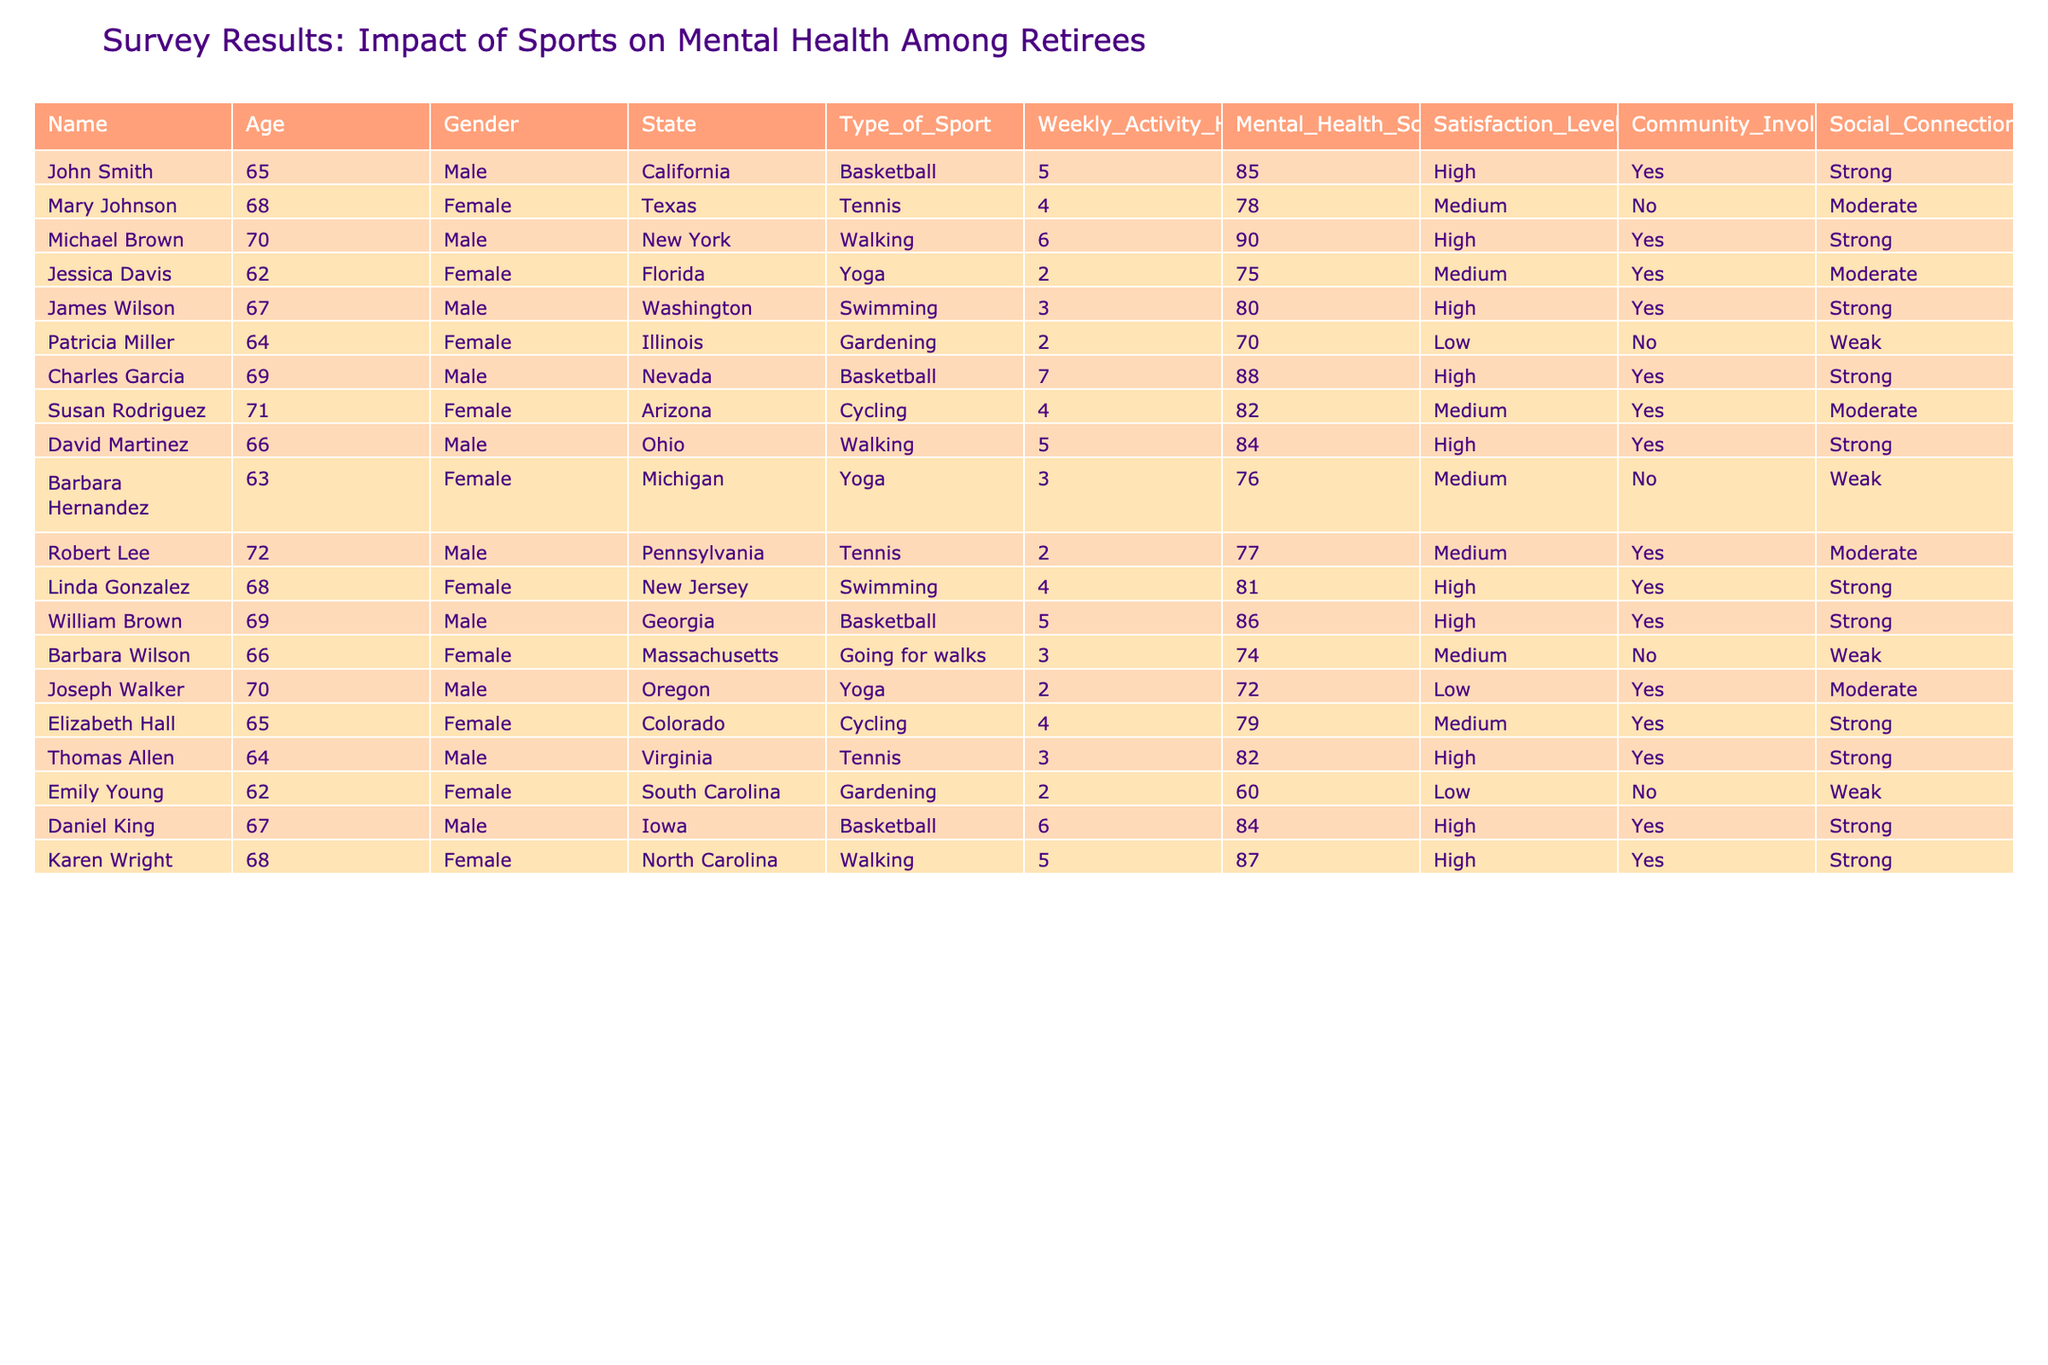What is the mental health score of John Smith? According to the table, John Smith has a mental health score of 85.
Answer: 85 Which retiree has the highest weekly activity hours? By looking at the table, Charles Garcia has the highest weekly activity hours at 7 hours.
Answer: 7 hours How many retirees participate in basketball? The table shows that 4 retirees are involved in basketball: John Smith, Charles Garcia, William Brown, and Daniel King.
Answer: 4 retirees What is the average mental health score of retirees who play yoga? The mental health scores for retirees participating in yoga are 75, 76, and 72. Adding them gives 223, and dividing by the 3 participants gives an average of 74.33.
Answer: 74.33 Is Susan Rodriguez involved in community activities? The table indicates that Susan Rodriguez does engage in community involvement.
Answer: Yes What is the satisfaction level of retirees who engage in swimming? The satisfaction levels for swimming retirees are high (80) and high (81). Average them, which gives 80.5.
Answer: 80.5 Which sport has the highest average mental health score among retirees? To find this, sum the mental health scores for each sport: Basketball (85+88+86+84=343, average 85.75), Tennis (78+77+82=237, average 79), Yoga (75+76+72=223, average 74.33), Walking (90+84+87=261, average 87), Swimming (80+81=161, average 80.5), Cycling (82+79=161, average 80.5), Gardening (70+60=130, average 65). Basketball has the highest average at 85.75.
Answer: Basketball Which gender has a higher proportion of retirees with a high satisfaction level? Looking at the table, 7 males have high satisfaction, while only 4 females have high satisfaction. To find the proportions, divide by the total number of each gender: 7/10 for males = 70%, and 4/10 for females = 40%. Males have the higher proportion.
Answer: Males What percentage of retirees with strong social connections participate in tennis? The table lists only 1 retiree with strong social connections who plays tennis (Thomas Allen). The total number of strong connections is 8. Calculate the percentage: (1/8)*100 = 12.5%.
Answer: 12.5% How does the mental health score correlate with weekly activity hours for retirees who play basketball? The mental health scores for basketball players are 85 (5 hours), 88 (7 hours), 86 (5 hours), and 84 (6 hours). The averages of hours are (5+7+5+6)/4=5.75 and scores are (85+88+86+84)/4=85.75, indicating a slight positive correlation.
Answer: Positive correlation 